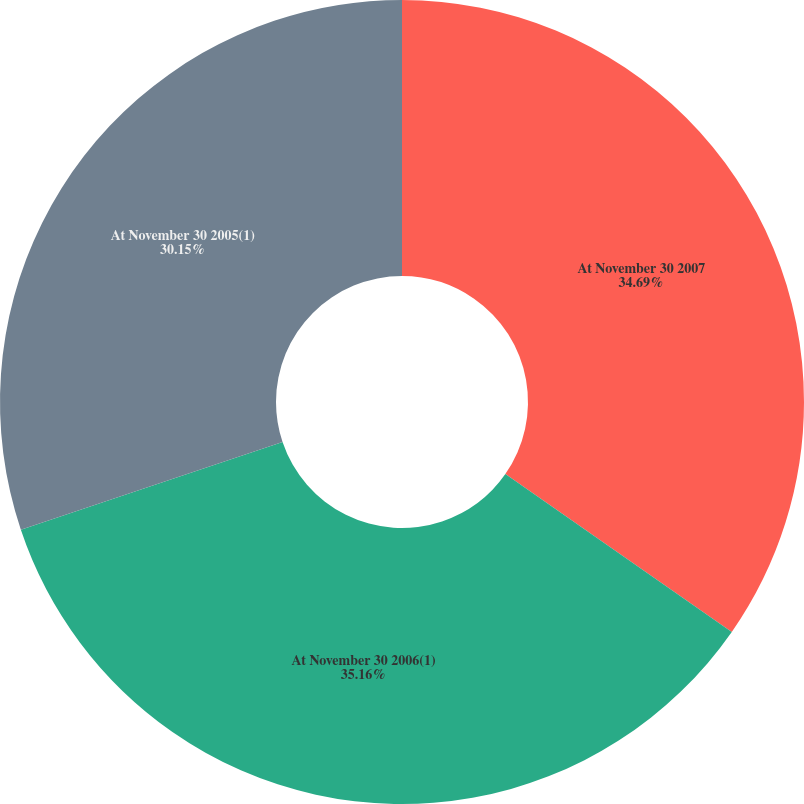Convert chart. <chart><loc_0><loc_0><loc_500><loc_500><pie_chart><fcel>At November 30 2007<fcel>At November 30 2006(1)<fcel>At November 30 2005(1)<nl><fcel>34.69%<fcel>35.16%<fcel>30.15%<nl></chart> 